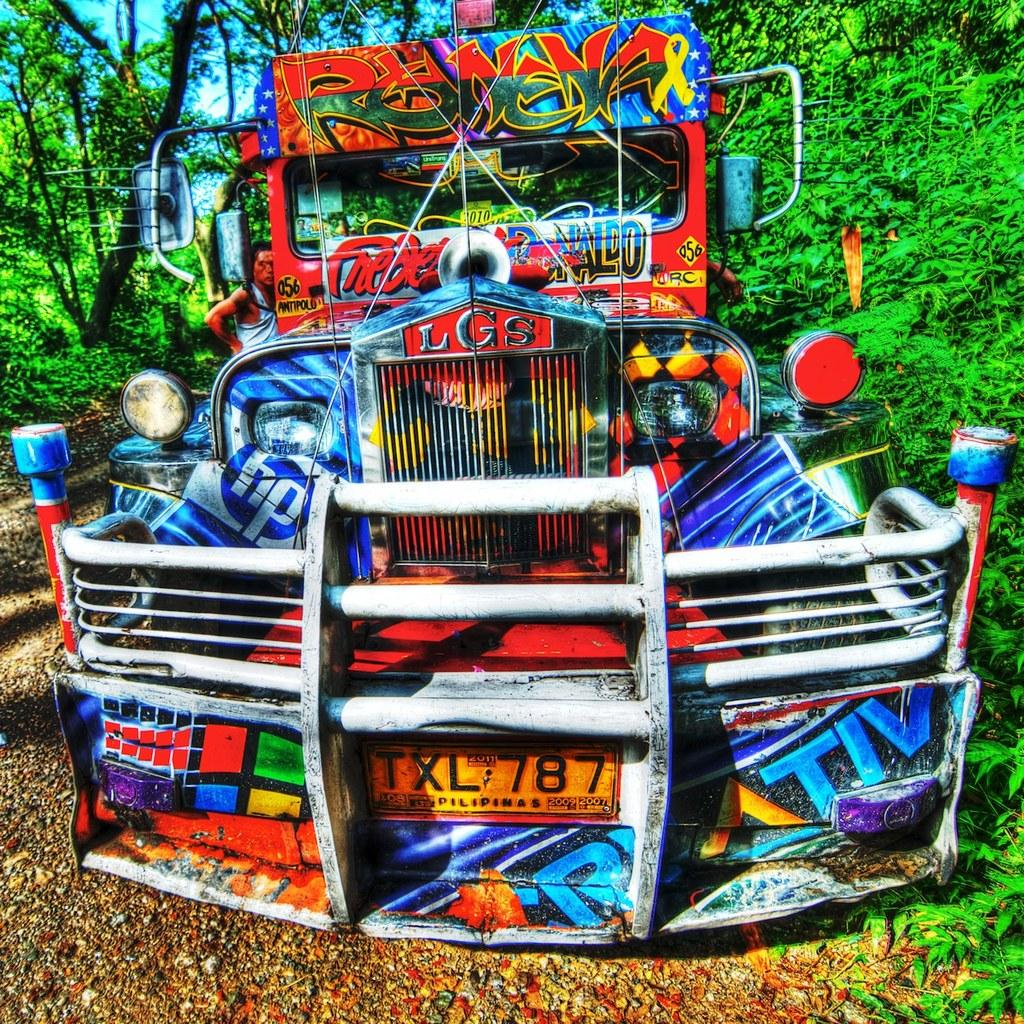What type of vehicle is depicted in the image? There is a painted colorful vehicle in the image. Where is the vehicle located? The vehicle is on land. What can be seen in the background of the image? There are many trees in the background of the image. Is there anyone present in the image? Yes, there is a person standing in the image. What type of drink is the manager holding in the image? There is no manager or drink present in the image. 